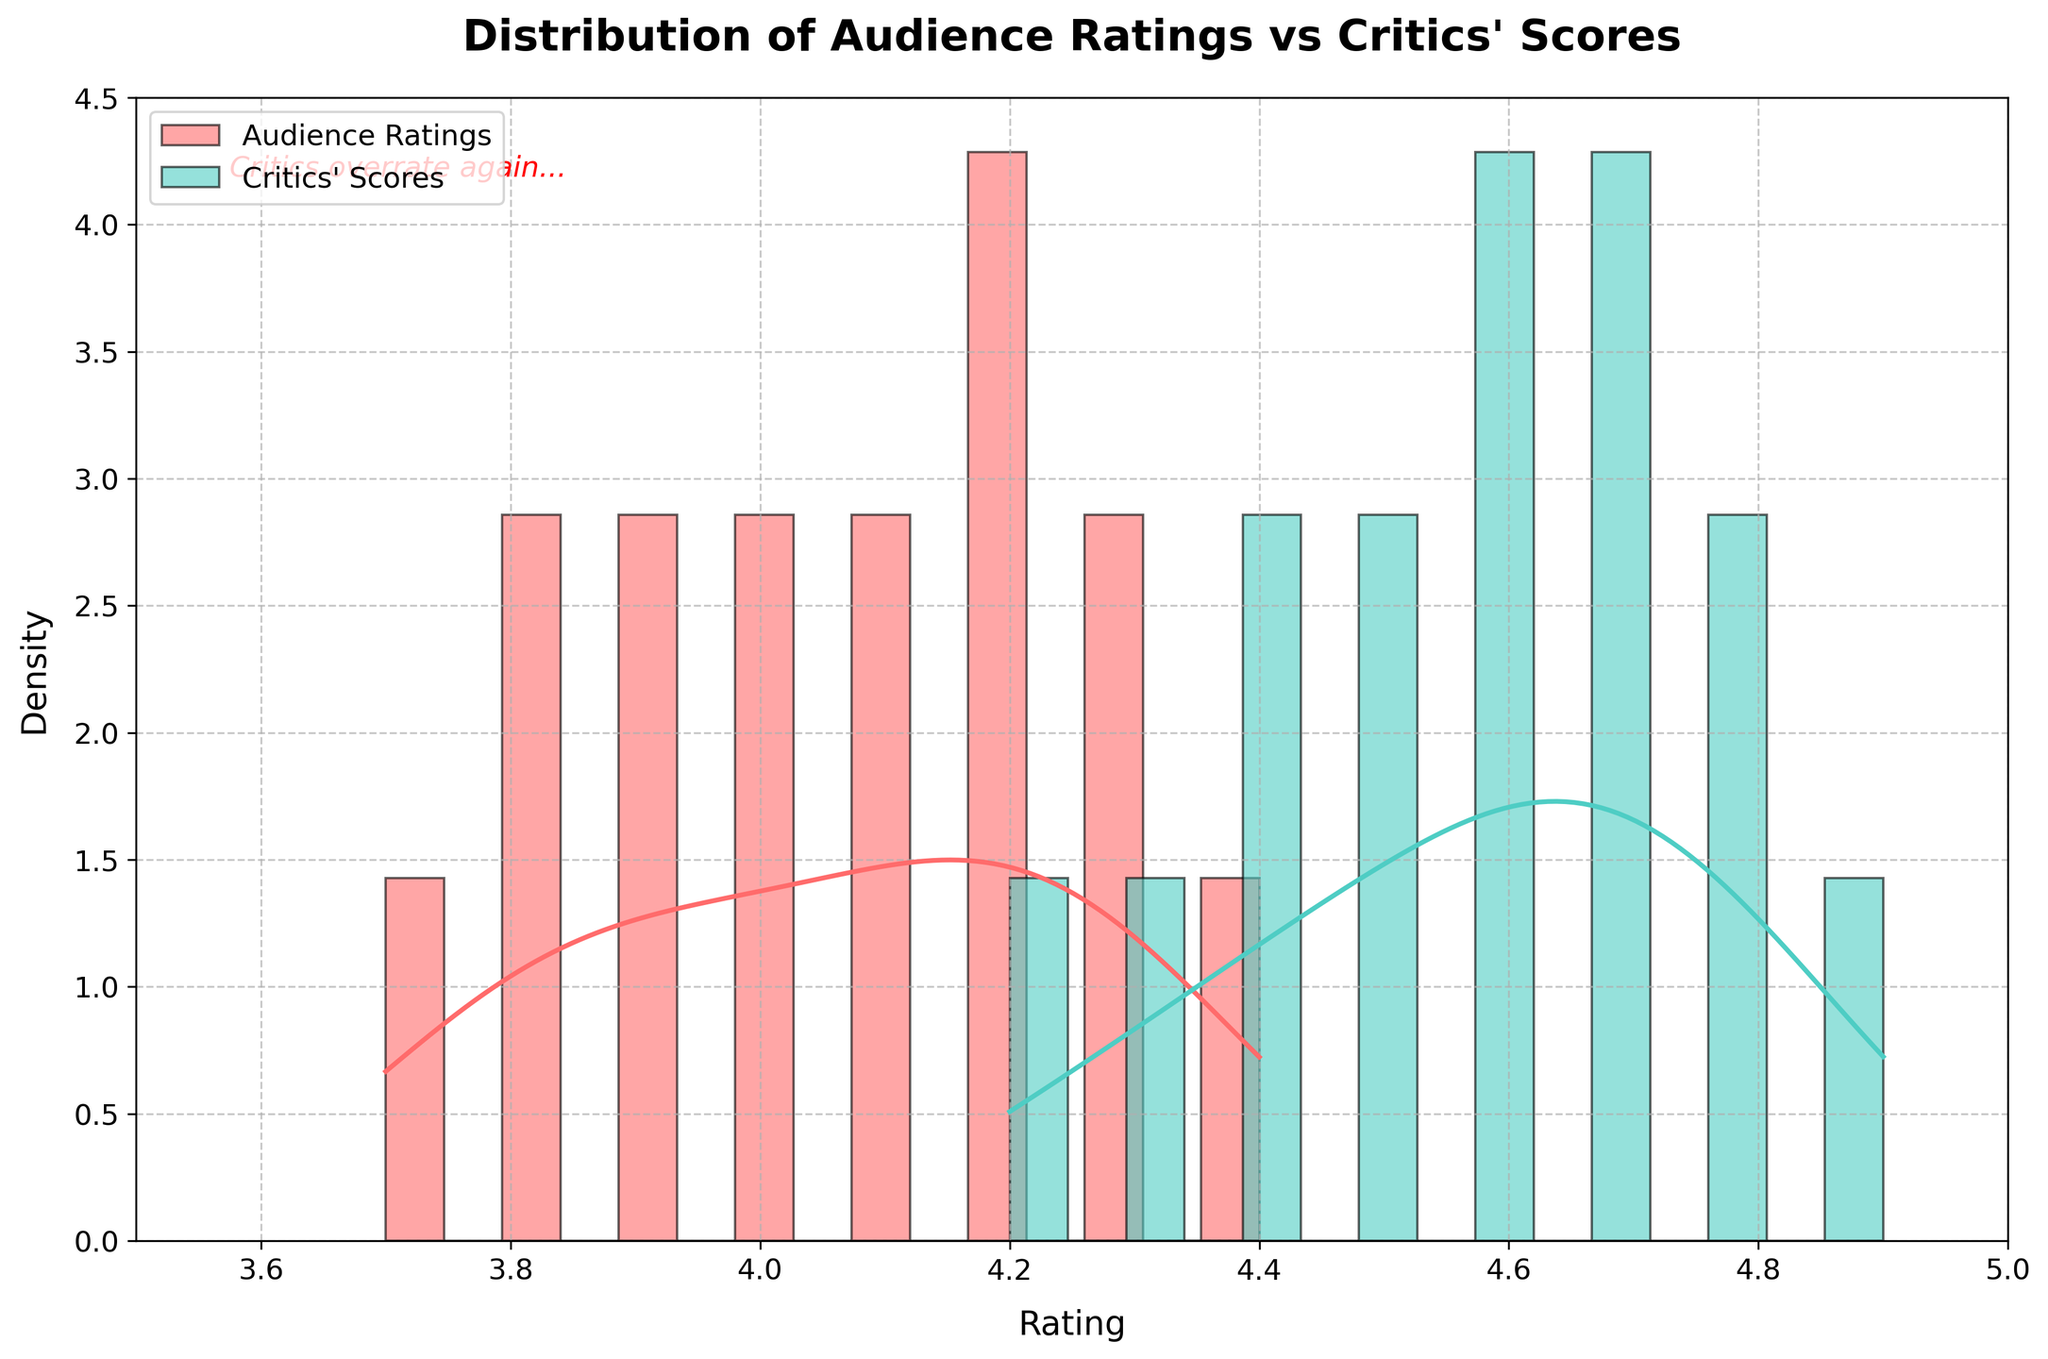What is the title of the figure? The title of the figure is displayed at the top of the chart. It is meant to provide a summary of what the figure represents.
Answer: Distribution of Audience Ratings vs Critics' Scores What are the labels of the X and Y axes? The labels for the axes can be found beside the axes themselves. The X-axis typically describes the data being measured, and the Y-axis often describes the measure of the data, in this case, 'Rating' and 'Density' respectively.
Answer: Rating (X-axis), Density (Y-axis) Which color represents the audience ratings? The color representations are indicated both visually on the histograms and within the legend of the plot. The audience ratings are shown in red.
Answer: Audience ratings are represented in red Which color represents the critics' scores? The colors for the critics' scores can be identified by looking at the legend of the plot. The critics' scores are shown in a teal-like color.
Answer: Critics' scores are represented in a teal-like color How do the KDE curves for the audience ratings and critics' scores compare in terms of their peaks? By observing the KDE curves, we can determine the differences in the peaks of the two distributions. The critics' scores curve appears to peak higher and at a higher rating than the audience ratings curve.
Answer: Critics' scores peak higher and at a higher rating than audience ratings Between the audience ratings and the critics' scores, which group shows a higher density around the rating of 4.6? By examining the height of the KDE curves around the rating of 4.6, we can see which group has a higher density. The critics' KDE curve is higher around this rating.
Answer: Critics' scores show a higher density around the rating of 4.6 Where is the snarky comment located on the figure? The snarky comment is embedded within the plot and usually positioned where it is visible but does not obstruct the data. It is located at the top-left of the figure.
Answer: Top-left corner of the figure What is the range of ratings displayed on the X-axis? The X-axis range can be identified by the limits marked on it. The range spans from the minimum rating to the maximum rating displayed.
Answer: 3.5 to 5.0 Do the critics' scores show a wider or narrower distribution compared to audience ratings? By comparing the spread of the histograms and KDEs for both audience ratings and critics' scores, we can determine the relative width of the distributions. The critics' scores show a slightly narrower distribution than the audience ratings.
Answer: Narrower Based on the KDE curves, around which rating is the audience most divided? By examining the peaks and variations in the KDE curve for audience ratings, we can identify the rating where the differences in density suggest a division. The audience's KDE curve does not show a pronounced peak, suggesting more division around the mean ratings.
Answer: Around 4.1-4.2 